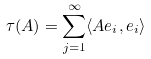Convert formula to latex. <formula><loc_0><loc_0><loc_500><loc_500>\tau ( A ) = \sum _ { j = 1 } ^ { \infty } \langle A e _ { i } , e _ { i } \rangle</formula> 